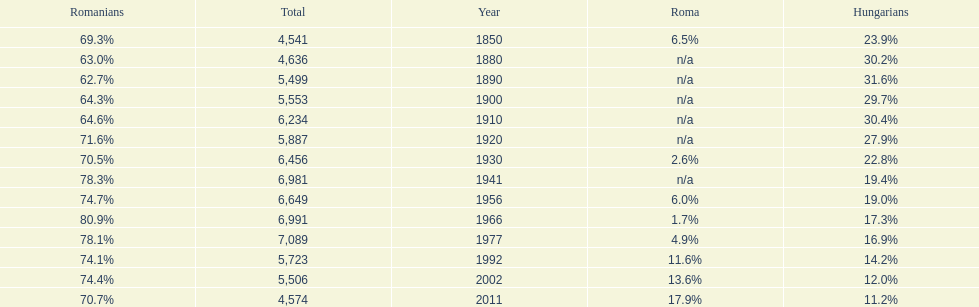Which year had a total of 6,981 and 19.4% hungarians? 1941. 